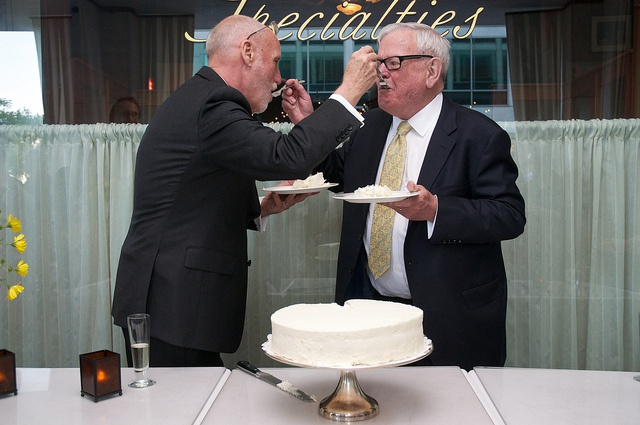Describe the objects in this image and their specific colors. I can see people in purple, black, lightpink, brown, and gray tones, people in purple, black, brown, darkgray, and lightgray tones, dining table in purple, lightgray, darkgray, and gray tones, cake in purple, ivory, lightgray, black, and gray tones, and tie in purple, tan, and darkgray tones in this image. 